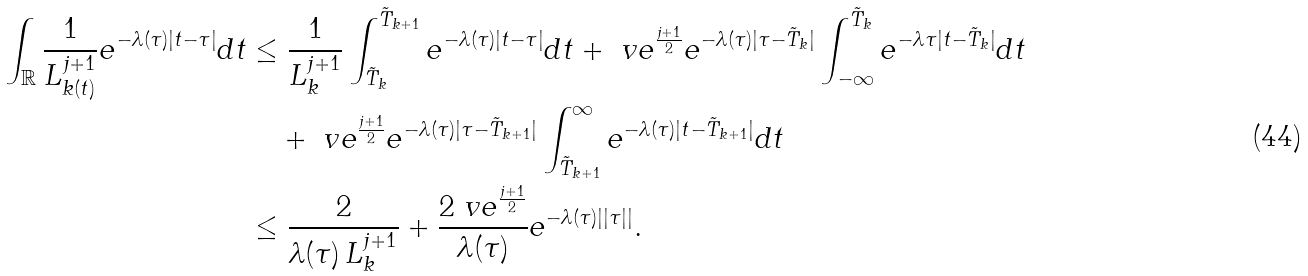<formula> <loc_0><loc_0><loc_500><loc_500>\int _ { \mathbb { R } } \frac { 1 } { L _ { k ( t ) } ^ { j + 1 } } e ^ { - \lambda ( \tau ) | t - \tau | } d t & \leq \frac { 1 } { L _ { k } ^ { j + 1 } } \int _ { \tilde { T } _ { k } } ^ { \tilde { T } _ { k + 1 } } e ^ { - \lambda ( \tau ) | t - \tau | } d t + \ v e ^ { \frac { j + 1 } { 2 } } e ^ { - \lambda ( \tau ) | \tau - \tilde { T } _ { k } | } \int _ { - \infty } ^ { \tilde { T } _ { k } } e ^ { - \lambda { \tau } | t - \tilde { T } _ { k } | } d t \\ & \quad + \ v e ^ { \frac { j + 1 } { 2 } } e ^ { - \lambda ( \tau ) | \tau - \tilde { T } _ { k + 1 } | } \int _ { \tilde { T } _ { k + 1 } } ^ { \infty } e ^ { - \lambda ( \tau ) | t - \tilde { T } _ { k + 1 } | } d t \\ & \leq \frac { 2 } { \lambda ( \tau ) \, L _ { k } ^ { j + 1 } } + \frac { 2 \ v e ^ { \frac { j + 1 } { 2 } } } { \lambda ( \tau ) } e ^ { - \lambda ( \tau ) | | \tau | | } .</formula> 